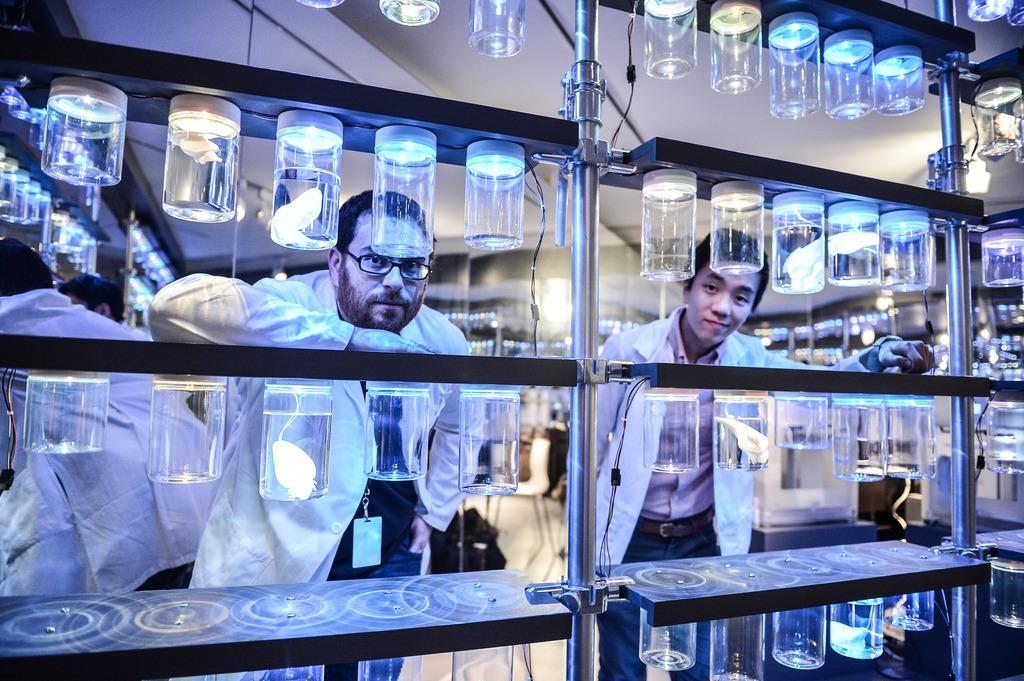Describe this image in one or two sentences. This is a laboratory. Here we can see a rack stand with some items in the jar and empty jars attached to the racks. In the background the image is blur but we can see few persons, chairs on the floor, lights on the ceiling and other objects. 